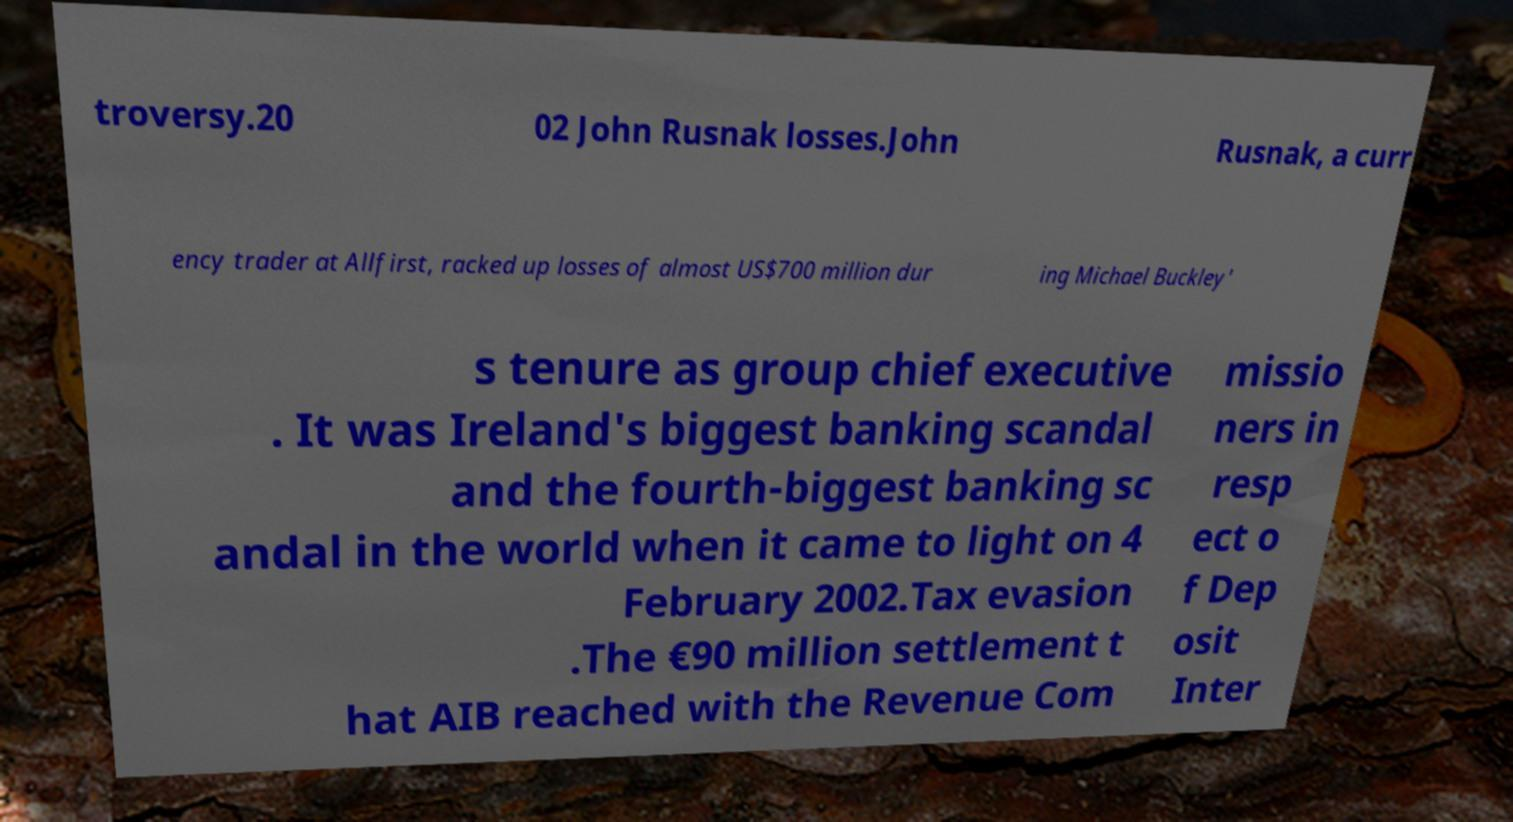Please identify and transcribe the text found in this image. troversy.20 02 John Rusnak losses.John Rusnak, a curr ency trader at Allfirst, racked up losses of almost US$700 million dur ing Michael Buckley' s tenure as group chief executive . It was Ireland's biggest banking scandal and the fourth-biggest banking sc andal in the world when it came to light on 4 February 2002.Tax evasion .The €90 million settlement t hat AIB reached with the Revenue Com missio ners in resp ect o f Dep osit Inter 